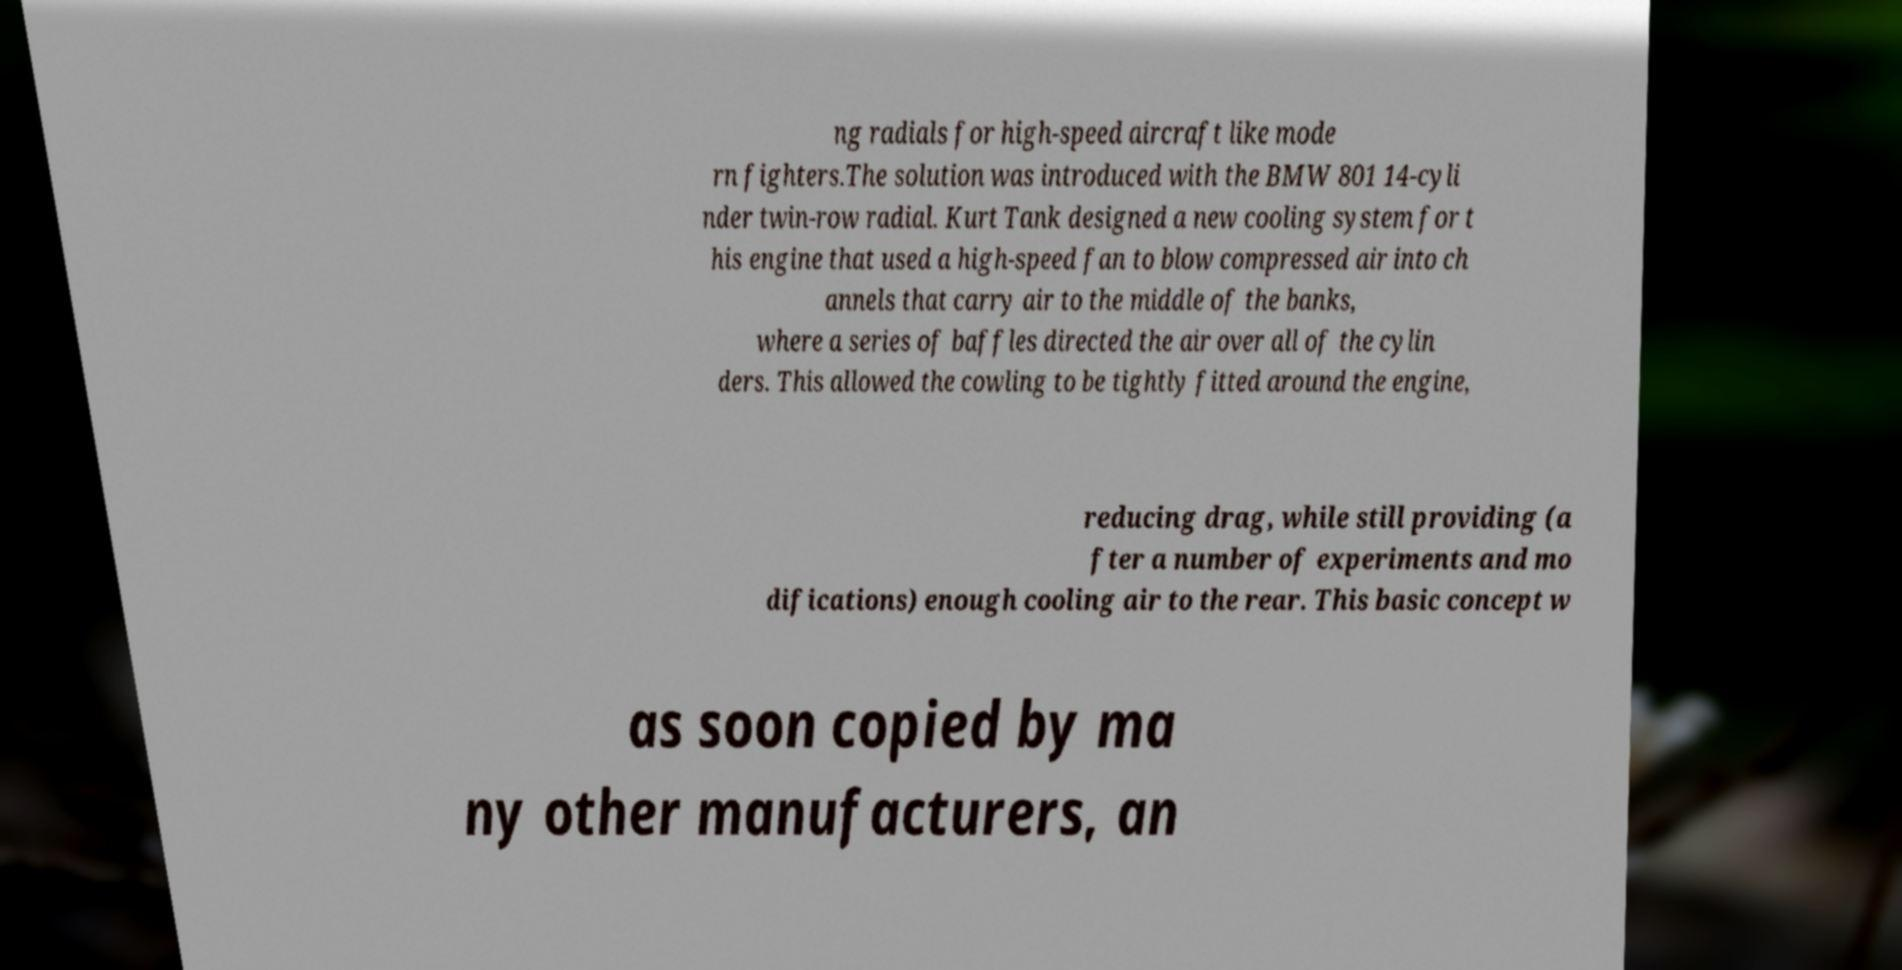There's text embedded in this image that I need extracted. Can you transcribe it verbatim? ng radials for high-speed aircraft like mode rn fighters.The solution was introduced with the BMW 801 14-cyli nder twin-row radial. Kurt Tank designed a new cooling system for t his engine that used a high-speed fan to blow compressed air into ch annels that carry air to the middle of the banks, where a series of baffles directed the air over all of the cylin ders. This allowed the cowling to be tightly fitted around the engine, reducing drag, while still providing (a fter a number of experiments and mo difications) enough cooling air to the rear. This basic concept w as soon copied by ma ny other manufacturers, an 